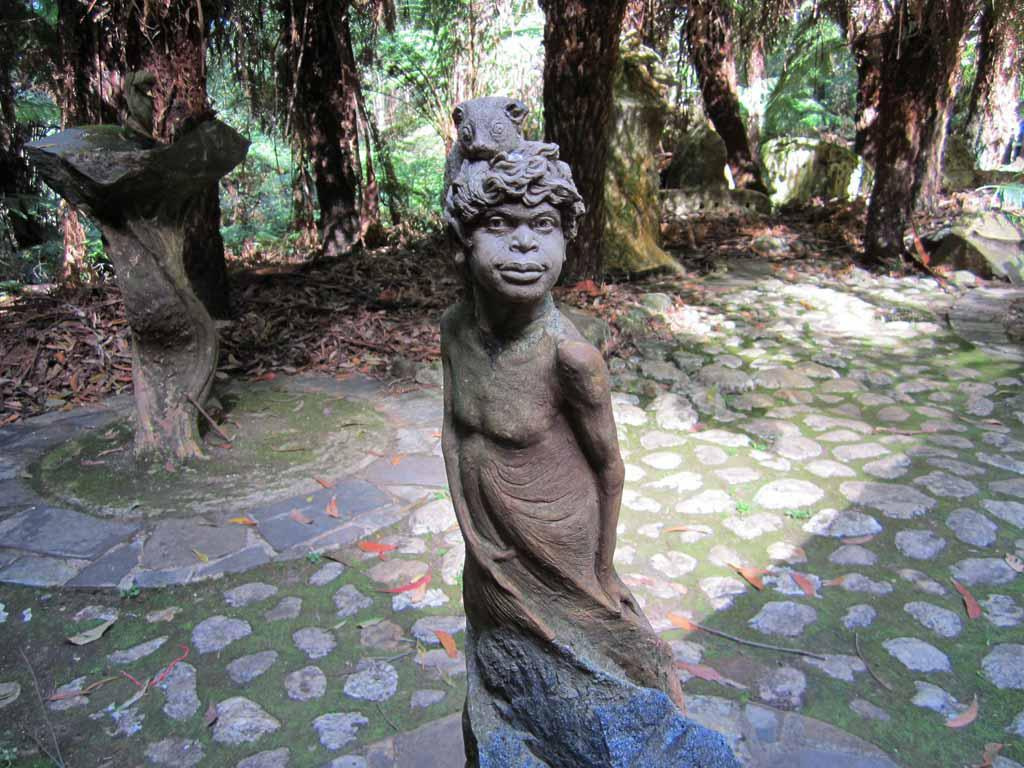What is the main subject of the image? There is a sculpture of a person in the image. What type of natural elements can be seen in the image? There are trees in the image. What type of path is visible in the image? There is a footpath in the image. What type of vegetation is present in the image? Dry grass is present in the image. What type of muscle is being exercised by the person in the sculpture? The sculpture is not a real person, so it cannot exercise any muscles. 